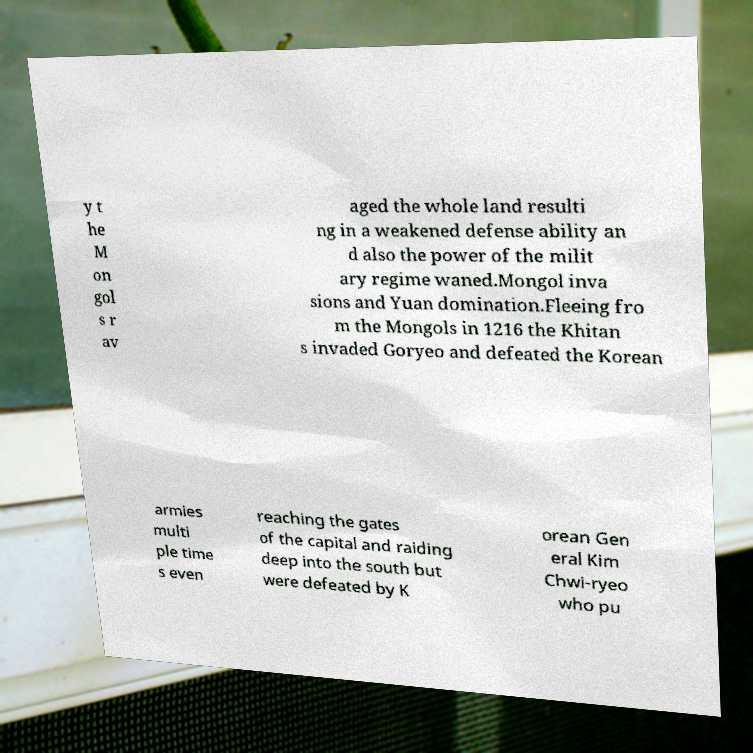There's text embedded in this image that I need extracted. Can you transcribe it verbatim? y t he M on gol s r av aged the whole land resulti ng in a weakened defense ability an d also the power of the milit ary regime waned.Mongol inva sions and Yuan domination.Fleeing fro m the Mongols in 1216 the Khitan s invaded Goryeo and defeated the Korean armies multi ple time s even reaching the gates of the capital and raiding deep into the south but were defeated by K orean Gen eral Kim Chwi-ryeo who pu 